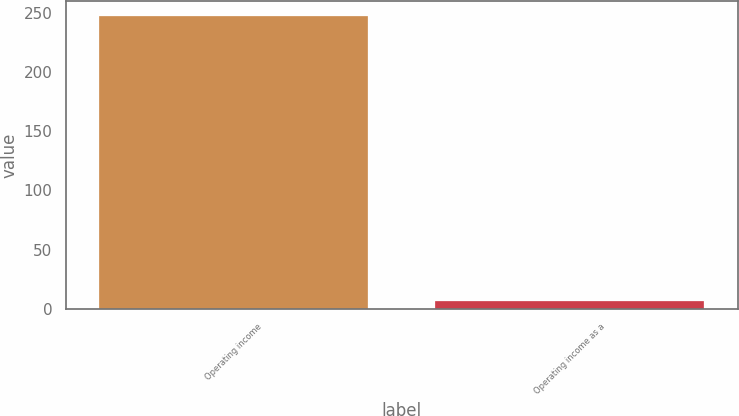<chart> <loc_0><loc_0><loc_500><loc_500><bar_chart><fcel>Operating income<fcel>Operating income as a<nl><fcel>247.5<fcel>6.5<nl></chart> 